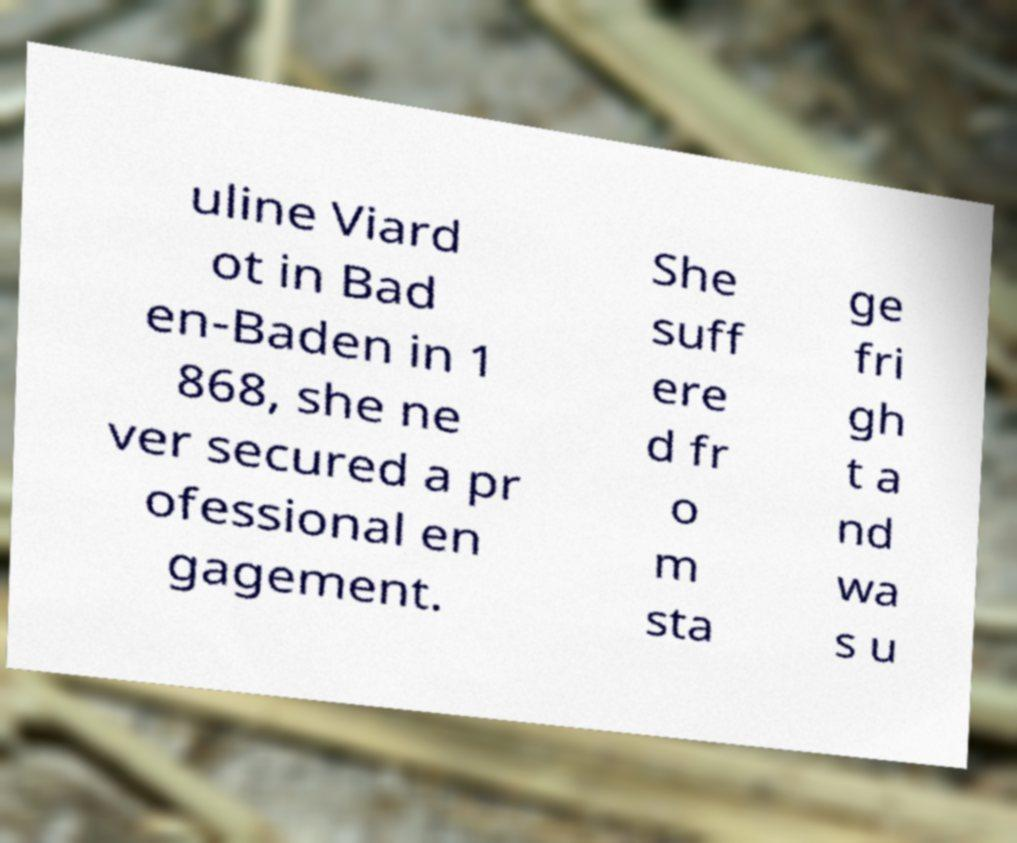Could you assist in decoding the text presented in this image and type it out clearly? uline Viard ot in Bad en-Baden in 1 868, she ne ver secured a pr ofessional en gagement. She suff ere d fr o m sta ge fri gh t a nd wa s u 